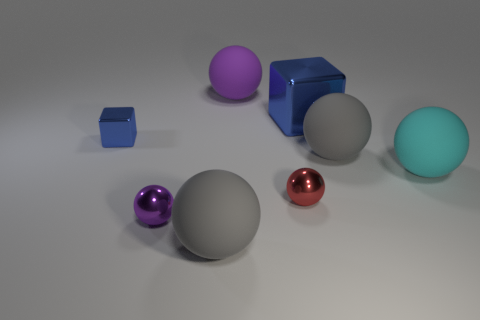Imagine this is a scene from a story. What could be happening here? In a story context, this scene might represent a mysterious collector's trove, where each sphere and cube stands for a different planet or element the collector has acquired. The varying sizes and finishes could symbolize the diversity of their origins. The central large matte sphere might be the prize of the collection, perhaps a rare object of immense power or significance within the narrative. 